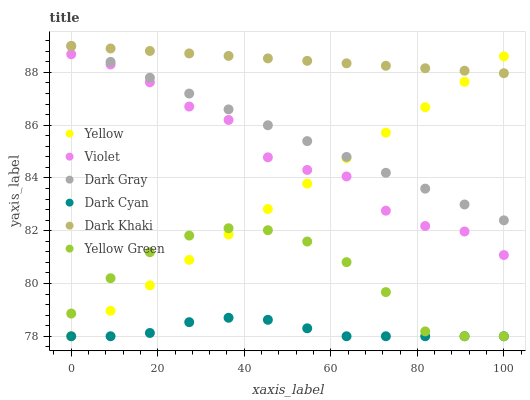Does Dark Cyan have the minimum area under the curve?
Answer yes or no. Yes. Does Dark Khaki have the maximum area under the curve?
Answer yes or no. Yes. Does Yellow Green have the minimum area under the curve?
Answer yes or no. No. Does Yellow Green have the maximum area under the curve?
Answer yes or no. No. Is Yellow the smoothest?
Answer yes or no. Yes. Is Violet the roughest?
Answer yes or no. Yes. Is Yellow Green the smoothest?
Answer yes or no. No. Is Yellow Green the roughest?
Answer yes or no. No. Does Yellow Green have the lowest value?
Answer yes or no. Yes. Does Dark Gray have the lowest value?
Answer yes or no. No. Does Dark Gray have the highest value?
Answer yes or no. Yes. Does Yellow Green have the highest value?
Answer yes or no. No. Is Dark Cyan less than Dark Gray?
Answer yes or no. Yes. Is Violet greater than Yellow Green?
Answer yes or no. Yes. Does Yellow intersect Violet?
Answer yes or no. Yes. Is Yellow less than Violet?
Answer yes or no. No. Is Yellow greater than Violet?
Answer yes or no. No. Does Dark Cyan intersect Dark Gray?
Answer yes or no. No. 